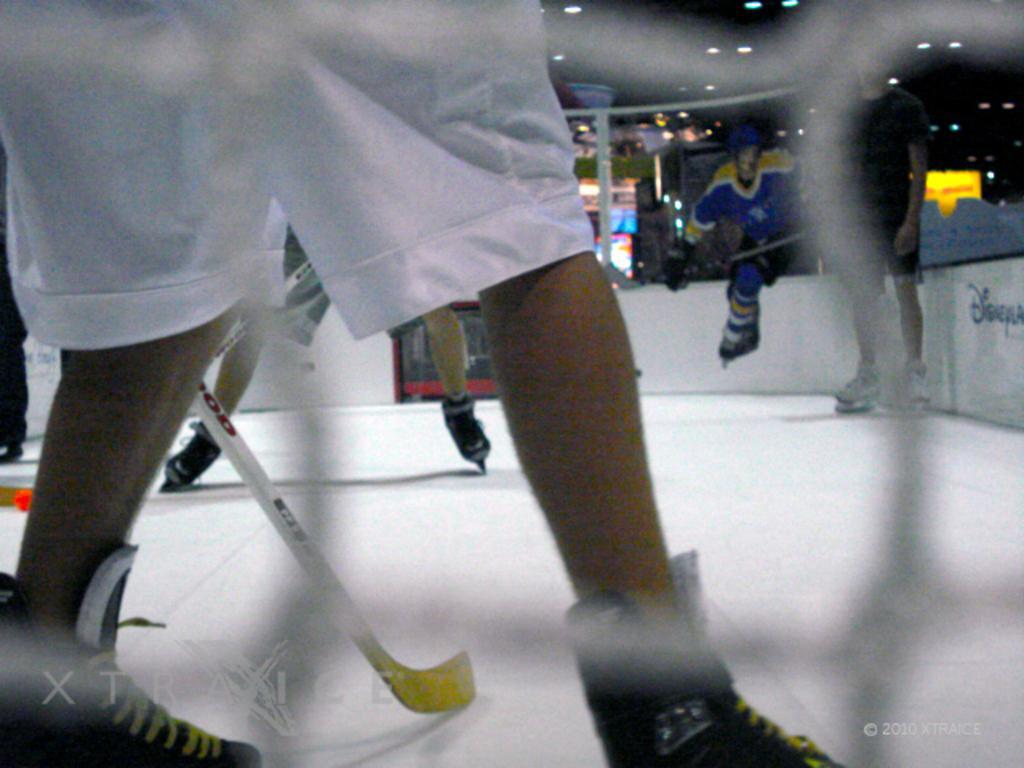Can you describe this image briefly? Here in this picture we can see a group of people playing ice hockey on the ice floor over there, as we can see skating shoes and hockey sticks present over there and on the roof we can see lights present over there. 